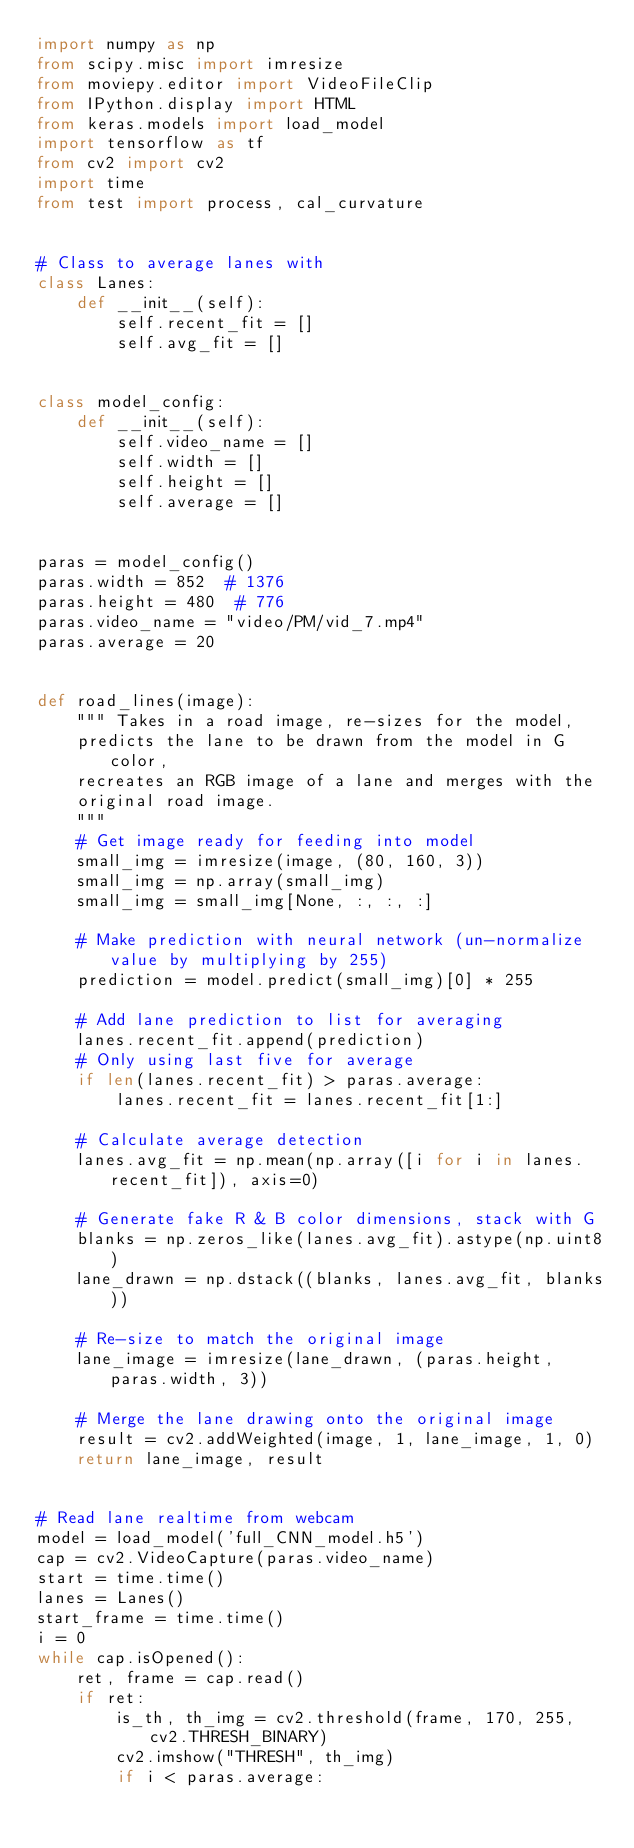Convert code to text. <code><loc_0><loc_0><loc_500><loc_500><_Python_>import numpy as np
from scipy.misc import imresize
from moviepy.editor import VideoFileClip
from IPython.display import HTML
from keras.models import load_model
import tensorflow as tf
from cv2 import cv2
import time
from test import process, cal_curvature


# Class to average lanes with
class Lanes:
    def __init__(self):
        self.recent_fit = []
        self.avg_fit = []


class model_config:
    def __init__(self):
        self.video_name = []
        self.width = []
        self.height = []
        self.average = []


paras = model_config()
paras.width = 852  # 1376
paras.height = 480  # 776
paras.video_name = "video/PM/vid_7.mp4"
paras.average = 20


def road_lines(image):
    """ Takes in a road image, re-sizes for the model,
    predicts the lane to be drawn from the model in G color,
    recreates an RGB image of a lane and merges with the
    original road image.
    """
    # Get image ready for feeding into model
    small_img = imresize(image, (80, 160, 3))
    small_img = np.array(small_img)
    small_img = small_img[None, :, :, :]

    # Make prediction with neural network (un-normalize value by multiplying by 255)
    prediction = model.predict(small_img)[0] * 255

    # Add lane prediction to list for averaging
    lanes.recent_fit.append(prediction)
    # Only using last five for average
    if len(lanes.recent_fit) > paras.average:
        lanes.recent_fit = lanes.recent_fit[1:]

    # Calculate average detection
    lanes.avg_fit = np.mean(np.array([i for i in lanes.recent_fit]), axis=0)

    # Generate fake R & B color dimensions, stack with G
    blanks = np.zeros_like(lanes.avg_fit).astype(np.uint8)
    lane_drawn = np.dstack((blanks, lanes.avg_fit, blanks))

    # Re-size to match the original image
    lane_image = imresize(lane_drawn, (paras.height, paras.width, 3))

    # Merge the lane drawing onto the original image
    result = cv2.addWeighted(image, 1, lane_image, 1, 0)
    return lane_image, result


# Read lane realtime from webcam
model = load_model('full_CNN_model.h5')
cap = cv2.VideoCapture(paras.video_name)
start = time.time()
lanes = Lanes()
start_frame = time.time()
i = 0
while cap.isOpened():
    ret, frame = cap.read()
    if ret:
        is_th, th_img = cv2.threshold(frame, 170, 255, cv2.THRESH_BINARY)
        cv2.imshow("THRESH", th_img)
        if i < paras.average:</code> 